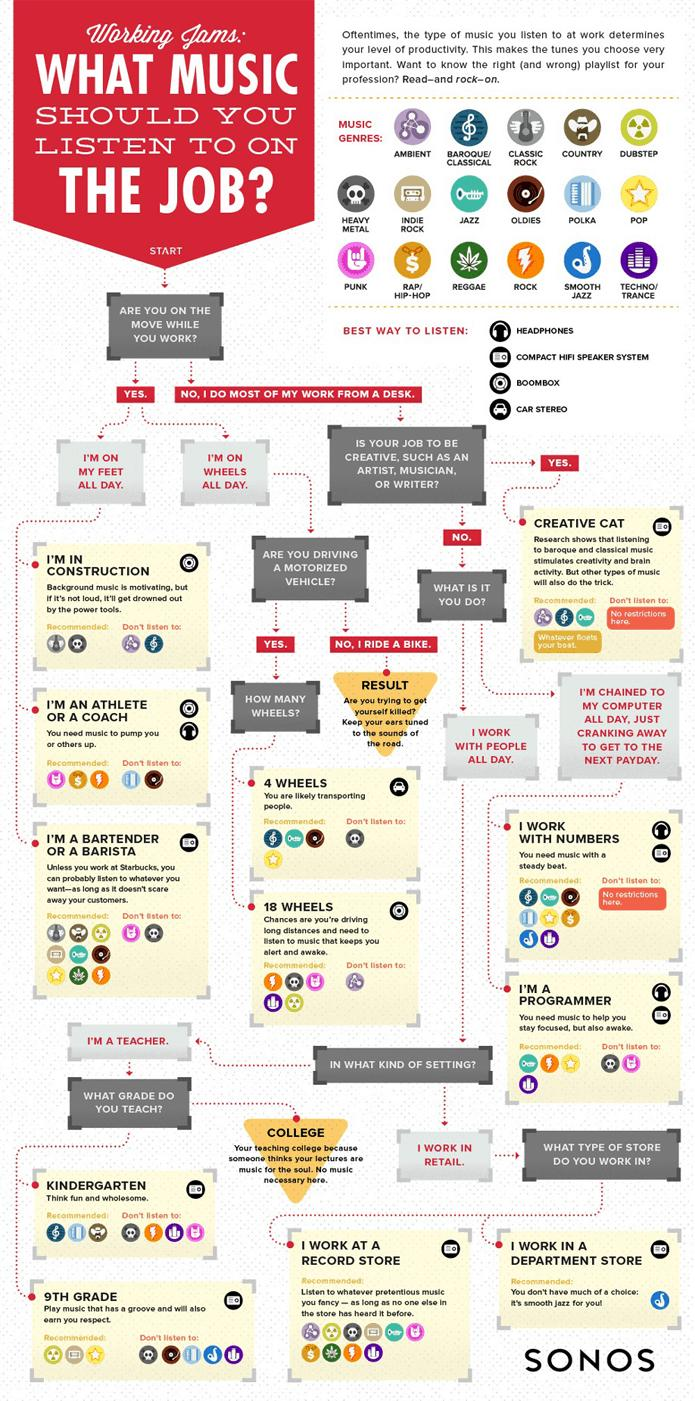Specify some key components in this picture. ROCK music is represented by a lightning symbol. It is recommended that individuals who are operating vehicles not play ambient music on all 18 wheels while driving, as this may distract them from the task at hand and increase the risk of accidents. The symbol for POP music is a star. There are 17 music genres that are being shown. Athletes and coaches are often looking for music genres that can provide them with the energy and motivation they need to perform at their best. Studies have shown that punk, rap/hip-hop, and rock music are all effective at increasing alertness and arousal, which can be beneficial for athletes and coaches. Therefore, it is recommended that athletes and coaches consider incorporating these genres into their workout playlists. 